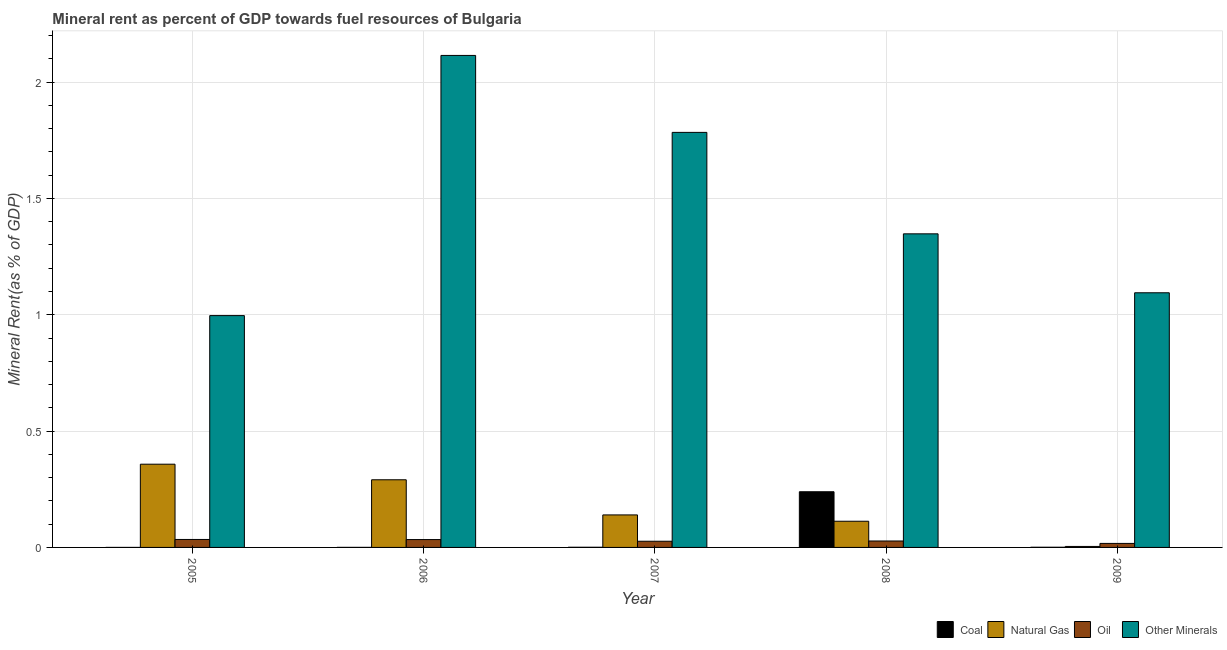How many different coloured bars are there?
Your answer should be compact. 4. Are the number of bars per tick equal to the number of legend labels?
Keep it short and to the point. Yes. How many bars are there on the 2nd tick from the left?
Your answer should be very brief. 4. How many bars are there on the 4th tick from the right?
Offer a very short reply. 4. What is the label of the 1st group of bars from the left?
Ensure brevity in your answer.  2005. What is the natural gas rent in 2009?
Keep it short and to the point. 0. Across all years, what is the maximum  rent of other minerals?
Provide a short and direct response. 2.11. Across all years, what is the minimum natural gas rent?
Offer a terse response. 0. In which year was the natural gas rent maximum?
Provide a succinct answer. 2005. In which year was the coal rent minimum?
Provide a succinct answer. 2005. What is the total oil rent in the graph?
Offer a terse response. 0.14. What is the difference between the  rent of other minerals in 2007 and that in 2008?
Provide a short and direct response. 0.44. What is the difference between the oil rent in 2005 and the  rent of other minerals in 2006?
Give a very brief answer. 0. What is the average coal rent per year?
Offer a terse response. 0.05. In the year 2008, what is the difference between the natural gas rent and coal rent?
Offer a very short reply. 0. What is the ratio of the  rent of other minerals in 2005 to that in 2009?
Provide a succinct answer. 0.91. Is the natural gas rent in 2006 less than that in 2007?
Your answer should be compact. No. Is the difference between the coal rent in 2006 and 2009 greater than the difference between the  rent of other minerals in 2006 and 2009?
Ensure brevity in your answer.  No. What is the difference between the highest and the second highest natural gas rent?
Provide a short and direct response. 0.07. What is the difference between the highest and the lowest  rent of other minerals?
Make the answer very short. 1.12. In how many years, is the natural gas rent greater than the average natural gas rent taken over all years?
Ensure brevity in your answer.  2. What does the 4th bar from the left in 2005 represents?
Make the answer very short. Other Minerals. What does the 4th bar from the right in 2008 represents?
Your response must be concise. Coal. How many bars are there?
Your response must be concise. 20. What is the difference between two consecutive major ticks on the Y-axis?
Offer a terse response. 0.5. Are the values on the major ticks of Y-axis written in scientific E-notation?
Offer a very short reply. No. Does the graph contain any zero values?
Make the answer very short. No. How are the legend labels stacked?
Give a very brief answer. Horizontal. What is the title of the graph?
Your answer should be compact. Mineral rent as percent of GDP towards fuel resources of Bulgaria. What is the label or title of the X-axis?
Your response must be concise. Year. What is the label or title of the Y-axis?
Give a very brief answer. Mineral Rent(as % of GDP). What is the Mineral Rent(as % of GDP) in Coal in 2005?
Ensure brevity in your answer.  6.50114927236494e-5. What is the Mineral Rent(as % of GDP) in Natural Gas in 2005?
Keep it short and to the point. 0.36. What is the Mineral Rent(as % of GDP) of Oil in 2005?
Provide a short and direct response. 0.03. What is the Mineral Rent(as % of GDP) in Other Minerals in 2005?
Your answer should be very brief. 1. What is the Mineral Rent(as % of GDP) of Coal in 2006?
Ensure brevity in your answer.  0. What is the Mineral Rent(as % of GDP) in Natural Gas in 2006?
Provide a short and direct response. 0.29. What is the Mineral Rent(as % of GDP) of Oil in 2006?
Offer a very short reply. 0.03. What is the Mineral Rent(as % of GDP) in Other Minerals in 2006?
Give a very brief answer. 2.11. What is the Mineral Rent(as % of GDP) of Coal in 2007?
Provide a succinct answer. 0. What is the Mineral Rent(as % of GDP) in Natural Gas in 2007?
Make the answer very short. 0.14. What is the Mineral Rent(as % of GDP) of Oil in 2007?
Your answer should be very brief. 0.03. What is the Mineral Rent(as % of GDP) of Other Minerals in 2007?
Your answer should be very brief. 1.78. What is the Mineral Rent(as % of GDP) in Coal in 2008?
Provide a short and direct response. 0.24. What is the Mineral Rent(as % of GDP) of Natural Gas in 2008?
Your answer should be very brief. 0.11. What is the Mineral Rent(as % of GDP) of Oil in 2008?
Your response must be concise. 0.03. What is the Mineral Rent(as % of GDP) of Other Minerals in 2008?
Provide a succinct answer. 1.35. What is the Mineral Rent(as % of GDP) of Coal in 2009?
Your answer should be compact. 0. What is the Mineral Rent(as % of GDP) in Natural Gas in 2009?
Keep it short and to the point. 0. What is the Mineral Rent(as % of GDP) of Oil in 2009?
Your answer should be compact. 0.02. What is the Mineral Rent(as % of GDP) in Other Minerals in 2009?
Make the answer very short. 1.09. Across all years, what is the maximum Mineral Rent(as % of GDP) in Coal?
Provide a succinct answer. 0.24. Across all years, what is the maximum Mineral Rent(as % of GDP) of Natural Gas?
Keep it short and to the point. 0.36. Across all years, what is the maximum Mineral Rent(as % of GDP) in Oil?
Provide a succinct answer. 0.03. Across all years, what is the maximum Mineral Rent(as % of GDP) of Other Minerals?
Give a very brief answer. 2.11. Across all years, what is the minimum Mineral Rent(as % of GDP) in Coal?
Make the answer very short. 6.50114927236494e-5. Across all years, what is the minimum Mineral Rent(as % of GDP) of Natural Gas?
Your answer should be compact. 0. Across all years, what is the minimum Mineral Rent(as % of GDP) in Oil?
Offer a terse response. 0.02. Across all years, what is the minimum Mineral Rent(as % of GDP) in Other Minerals?
Your answer should be very brief. 1. What is the total Mineral Rent(as % of GDP) in Coal in the graph?
Your answer should be compact. 0.24. What is the total Mineral Rent(as % of GDP) of Natural Gas in the graph?
Your response must be concise. 0.91. What is the total Mineral Rent(as % of GDP) of Oil in the graph?
Your response must be concise. 0.14. What is the total Mineral Rent(as % of GDP) of Other Minerals in the graph?
Provide a short and direct response. 7.34. What is the difference between the Mineral Rent(as % of GDP) of Coal in 2005 and that in 2006?
Your answer should be compact. -0. What is the difference between the Mineral Rent(as % of GDP) of Natural Gas in 2005 and that in 2006?
Ensure brevity in your answer.  0.07. What is the difference between the Mineral Rent(as % of GDP) in Other Minerals in 2005 and that in 2006?
Offer a very short reply. -1.12. What is the difference between the Mineral Rent(as % of GDP) of Coal in 2005 and that in 2007?
Your answer should be compact. -0. What is the difference between the Mineral Rent(as % of GDP) of Natural Gas in 2005 and that in 2007?
Provide a succinct answer. 0.22. What is the difference between the Mineral Rent(as % of GDP) of Oil in 2005 and that in 2007?
Give a very brief answer. 0.01. What is the difference between the Mineral Rent(as % of GDP) of Other Minerals in 2005 and that in 2007?
Provide a succinct answer. -0.79. What is the difference between the Mineral Rent(as % of GDP) in Coal in 2005 and that in 2008?
Make the answer very short. -0.24. What is the difference between the Mineral Rent(as % of GDP) of Natural Gas in 2005 and that in 2008?
Ensure brevity in your answer.  0.25. What is the difference between the Mineral Rent(as % of GDP) in Oil in 2005 and that in 2008?
Offer a terse response. 0.01. What is the difference between the Mineral Rent(as % of GDP) in Other Minerals in 2005 and that in 2008?
Provide a short and direct response. -0.35. What is the difference between the Mineral Rent(as % of GDP) of Coal in 2005 and that in 2009?
Give a very brief answer. -0. What is the difference between the Mineral Rent(as % of GDP) in Natural Gas in 2005 and that in 2009?
Offer a terse response. 0.35. What is the difference between the Mineral Rent(as % of GDP) in Oil in 2005 and that in 2009?
Give a very brief answer. 0.02. What is the difference between the Mineral Rent(as % of GDP) of Other Minerals in 2005 and that in 2009?
Give a very brief answer. -0.1. What is the difference between the Mineral Rent(as % of GDP) in Coal in 2006 and that in 2007?
Make the answer very short. -0. What is the difference between the Mineral Rent(as % of GDP) of Natural Gas in 2006 and that in 2007?
Your answer should be very brief. 0.15. What is the difference between the Mineral Rent(as % of GDP) of Oil in 2006 and that in 2007?
Offer a terse response. 0.01. What is the difference between the Mineral Rent(as % of GDP) in Other Minerals in 2006 and that in 2007?
Offer a very short reply. 0.33. What is the difference between the Mineral Rent(as % of GDP) of Coal in 2006 and that in 2008?
Ensure brevity in your answer.  -0.24. What is the difference between the Mineral Rent(as % of GDP) of Natural Gas in 2006 and that in 2008?
Ensure brevity in your answer.  0.18. What is the difference between the Mineral Rent(as % of GDP) in Oil in 2006 and that in 2008?
Your answer should be very brief. 0.01. What is the difference between the Mineral Rent(as % of GDP) in Other Minerals in 2006 and that in 2008?
Your answer should be compact. 0.77. What is the difference between the Mineral Rent(as % of GDP) in Coal in 2006 and that in 2009?
Provide a succinct answer. -0. What is the difference between the Mineral Rent(as % of GDP) of Natural Gas in 2006 and that in 2009?
Give a very brief answer. 0.29. What is the difference between the Mineral Rent(as % of GDP) of Oil in 2006 and that in 2009?
Make the answer very short. 0.02. What is the difference between the Mineral Rent(as % of GDP) in Other Minerals in 2006 and that in 2009?
Make the answer very short. 1.02. What is the difference between the Mineral Rent(as % of GDP) in Coal in 2007 and that in 2008?
Offer a terse response. -0.24. What is the difference between the Mineral Rent(as % of GDP) in Natural Gas in 2007 and that in 2008?
Your answer should be very brief. 0.03. What is the difference between the Mineral Rent(as % of GDP) in Oil in 2007 and that in 2008?
Provide a short and direct response. -0. What is the difference between the Mineral Rent(as % of GDP) of Other Minerals in 2007 and that in 2008?
Keep it short and to the point. 0.44. What is the difference between the Mineral Rent(as % of GDP) in Coal in 2007 and that in 2009?
Make the answer very short. -0. What is the difference between the Mineral Rent(as % of GDP) of Natural Gas in 2007 and that in 2009?
Your answer should be very brief. 0.14. What is the difference between the Mineral Rent(as % of GDP) of Oil in 2007 and that in 2009?
Provide a succinct answer. 0.01. What is the difference between the Mineral Rent(as % of GDP) in Other Minerals in 2007 and that in 2009?
Provide a succinct answer. 0.69. What is the difference between the Mineral Rent(as % of GDP) of Coal in 2008 and that in 2009?
Your answer should be compact. 0.24. What is the difference between the Mineral Rent(as % of GDP) in Natural Gas in 2008 and that in 2009?
Offer a very short reply. 0.11. What is the difference between the Mineral Rent(as % of GDP) in Oil in 2008 and that in 2009?
Provide a short and direct response. 0.01. What is the difference between the Mineral Rent(as % of GDP) of Other Minerals in 2008 and that in 2009?
Your answer should be very brief. 0.25. What is the difference between the Mineral Rent(as % of GDP) of Coal in 2005 and the Mineral Rent(as % of GDP) of Natural Gas in 2006?
Ensure brevity in your answer.  -0.29. What is the difference between the Mineral Rent(as % of GDP) in Coal in 2005 and the Mineral Rent(as % of GDP) in Oil in 2006?
Provide a succinct answer. -0.03. What is the difference between the Mineral Rent(as % of GDP) of Coal in 2005 and the Mineral Rent(as % of GDP) of Other Minerals in 2006?
Provide a short and direct response. -2.11. What is the difference between the Mineral Rent(as % of GDP) of Natural Gas in 2005 and the Mineral Rent(as % of GDP) of Oil in 2006?
Your answer should be very brief. 0.32. What is the difference between the Mineral Rent(as % of GDP) of Natural Gas in 2005 and the Mineral Rent(as % of GDP) of Other Minerals in 2006?
Keep it short and to the point. -1.76. What is the difference between the Mineral Rent(as % of GDP) in Oil in 2005 and the Mineral Rent(as % of GDP) in Other Minerals in 2006?
Your answer should be compact. -2.08. What is the difference between the Mineral Rent(as % of GDP) of Coal in 2005 and the Mineral Rent(as % of GDP) of Natural Gas in 2007?
Keep it short and to the point. -0.14. What is the difference between the Mineral Rent(as % of GDP) of Coal in 2005 and the Mineral Rent(as % of GDP) of Oil in 2007?
Your answer should be compact. -0.03. What is the difference between the Mineral Rent(as % of GDP) in Coal in 2005 and the Mineral Rent(as % of GDP) in Other Minerals in 2007?
Offer a terse response. -1.78. What is the difference between the Mineral Rent(as % of GDP) of Natural Gas in 2005 and the Mineral Rent(as % of GDP) of Oil in 2007?
Your answer should be very brief. 0.33. What is the difference between the Mineral Rent(as % of GDP) of Natural Gas in 2005 and the Mineral Rent(as % of GDP) of Other Minerals in 2007?
Provide a succinct answer. -1.43. What is the difference between the Mineral Rent(as % of GDP) in Oil in 2005 and the Mineral Rent(as % of GDP) in Other Minerals in 2007?
Keep it short and to the point. -1.75. What is the difference between the Mineral Rent(as % of GDP) in Coal in 2005 and the Mineral Rent(as % of GDP) in Natural Gas in 2008?
Make the answer very short. -0.11. What is the difference between the Mineral Rent(as % of GDP) in Coal in 2005 and the Mineral Rent(as % of GDP) in Oil in 2008?
Give a very brief answer. -0.03. What is the difference between the Mineral Rent(as % of GDP) in Coal in 2005 and the Mineral Rent(as % of GDP) in Other Minerals in 2008?
Your response must be concise. -1.35. What is the difference between the Mineral Rent(as % of GDP) in Natural Gas in 2005 and the Mineral Rent(as % of GDP) in Oil in 2008?
Your answer should be very brief. 0.33. What is the difference between the Mineral Rent(as % of GDP) of Natural Gas in 2005 and the Mineral Rent(as % of GDP) of Other Minerals in 2008?
Provide a succinct answer. -0.99. What is the difference between the Mineral Rent(as % of GDP) of Oil in 2005 and the Mineral Rent(as % of GDP) of Other Minerals in 2008?
Your answer should be very brief. -1.31. What is the difference between the Mineral Rent(as % of GDP) in Coal in 2005 and the Mineral Rent(as % of GDP) in Natural Gas in 2009?
Make the answer very short. -0. What is the difference between the Mineral Rent(as % of GDP) of Coal in 2005 and the Mineral Rent(as % of GDP) of Oil in 2009?
Provide a short and direct response. -0.02. What is the difference between the Mineral Rent(as % of GDP) in Coal in 2005 and the Mineral Rent(as % of GDP) in Other Minerals in 2009?
Provide a short and direct response. -1.09. What is the difference between the Mineral Rent(as % of GDP) of Natural Gas in 2005 and the Mineral Rent(as % of GDP) of Oil in 2009?
Keep it short and to the point. 0.34. What is the difference between the Mineral Rent(as % of GDP) of Natural Gas in 2005 and the Mineral Rent(as % of GDP) of Other Minerals in 2009?
Give a very brief answer. -0.74. What is the difference between the Mineral Rent(as % of GDP) in Oil in 2005 and the Mineral Rent(as % of GDP) in Other Minerals in 2009?
Make the answer very short. -1.06. What is the difference between the Mineral Rent(as % of GDP) of Coal in 2006 and the Mineral Rent(as % of GDP) of Natural Gas in 2007?
Give a very brief answer. -0.14. What is the difference between the Mineral Rent(as % of GDP) of Coal in 2006 and the Mineral Rent(as % of GDP) of Oil in 2007?
Your answer should be compact. -0.03. What is the difference between the Mineral Rent(as % of GDP) in Coal in 2006 and the Mineral Rent(as % of GDP) in Other Minerals in 2007?
Provide a succinct answer. -1.78. What is the difference between the Mineral Rent(as % of GDP) of Natural Gas in 2006 and the Mineral Rent(as % of GDP) of Oil in 2007?
Your answer should be very brief. 0.26. What is the difference between the Mineral Rent(as % of GDP) in Natural Gas in 2006 and the Mineral Rent(as % of GDP) in Other Minerals in 2007?
Provide a short and direct response. -1.49. What is the difference between the Mineral Rent(as % of GDP) in Oil in 2006 and the Mineral Rent(as % of GDP) in Other Minerals in 2007?
Offer a terse response. -1.75. What is the difference between the Mineral Rent(as % of GDP) in Coal in 2006 and the Mineral Rent(as % of GDP) in Natural Gas in 2008?
Make the answer very short. -0.11. What is the difference between the Mineral Rent(as % of GDP) of Coal in 2006 and the Mineral Rent(as % of GDP) of Oil in 2008?
Make the answer very short. -0.03. What is the difference between the Mineral Rent(as % of GDP) in Coal in 2006 and the Mineral Rent(as % of GDP) in Other Minerals in 2008?
Your answer should be compact. -1.35. What is the difference between the Mineral Rent(as % of GDP) of Natural Gas in 2006 and the Mineral Rent(as % of GDP) of Oil in 2008?
Provide a short and direct response. 0.26. What is the difference between the Mineral Rent(as % of GDP) of Natural Gas in 2006 and the Mineral Rent(as % of GDP) of Other Minerals in 2008?
Make the answer very short. -1.06. What is the difference between the Mineral Rent(as % of GDP) in Oil in 2006 and the Mineral Rent(as % of GDP) in Other Minerals in 2008?
Make the answer very short. -1.31. What is the difference between the Mineral Rent(as % of GDP) of Coal in 2006 and the Mineral Rent(as % of GDP) of Natural Gas in 2009?
Make the answer very short. -0. What is the difference between the Mineral Rent(as % of GDP) in Coal in 2006 and the Mineral Rent(as % of GDP) in Oil in 2009?
Your answer should be very brief. -0.02. What is the difference between the Mineral Rent(as % of GDP) of Coal in 2006 and the Mineral Rent(as % of GDP) of Other Minerals in 2009?
Offer a very short reply. -1.09. What is the difference between the Mineral Rent(as % of GDP) of Natural Gas in 2006 and the Mineral Rent(as % of GDP) of Oil in 2009?
Provide a succinct answer. 0.27. What is the difference between the Mineral Rent(as % of GDP) in Natural Gas in 2006 and the Mineral Rent(as % of GDP) in Other Minerals in 2009?
Your answer should be very brief. -0.8. What is the difference between the Mineral Rent(as % of GDP) in Oil in 2006 and the Mineral Rent(as % of GDP) in Other Minerals in 2009?
Offer a very short reply. -1.06. What is the difference between the Mineral Rent(as % of GDP) in Coal in 2007 and the Mineral Rent(as % of GDP) in Natural Gas in 2008?
Make the answer very short. -0.11. What is the difference between the Mineral Rent(as % of GDP) in Coal in 2007 and the Mineral Rent(as % of GDP) in Oil in 2008?
Your answer should be very brief. -0.03. What is the difference between the Mineral Rent(as % of GDP) of Coal in 2007 and the Mineral Rent(as % of GDP) of Other Minerals in 2008?
Make the answer very short. -1.35. What is the difference between the Mineral Rent(as % of GDP) in Natural Gas in 2007 and the Mineral Rent(as % of GDP) in Oil in 2008?
Provide a succinct answer. 0.11. What is the difference between the Mineral Rent(as % of GDP) in Natural Gas in 2007 and the Mineral Rent(as % of GDP) in Other Minerals in 2008?
Offer a terse response. -1.21. What is the difference between the Mineral Rent(as % of GDP) of Oil in 2007 and the Mineral Rent(as % of GDP) of Other Minerals in 2008?
Keep it short and to the point. -1.32. What is the difference between the Mineral Rent(as % of GDP) in Coal in 2007 and the Mineral Rent(as % of GDP) in Natural Gas in 2009?
Make the answer very short. -0. What is the difference between the Mineral Rent(as % of GDP) of Coal in 2007 and the Mineral Rent(as % of GDP) of Oil in 2009?
Offer a very short reply. -0.02. What is the difference between the Mineral Rent(as % of GDP) in Coal in 2007 and the Mineral Rent(as % of GDP) in Other Minerals in 2009?
Your response must be concise. -1.09. What is the difference between the Mineral Rent(as % of GDP) of Natural Gas in 2007 and the Mineral Rent(as % of GDP) of Oil in 2009?
Your answer should be compact. 0.12. What is the difference between the Mineral Rent(as % of GDP) in Natural Gas in 2007 and the Mineral Rent(as % of GDP) in Other Minerals in 2009?
Your answer should be very brief. -0.95. What is the difference between the Mineral Rent(as % of GDP) in Oil in 2007 and the Mineral Rent(as % of GDP) in Other Minerals in 2009?
Keep it short and to the point. -1.07. What is the difference between the Mineral Rent(as % of GDP) in Coal in 2008 and the Mineral Rent(as % of GDP) in Natural Gas in 2009?
Your answer should be compact. 0.24. What is the difference between the Mineral Rent(as % of GDP) in Coal in 2008 and the Mineral Rent(as % of GDP) in Oil in 2009?
Your answer should be very brief. 0.22. What is the difference between the Mineral Rent(as % of GDP) in Coal in 2008 and the Mineral Rent(as % of GDP) in Other Minerals in 2009?
Provide a succinct answer. -0.86. What is the difference between the Mineral Rent(as % of GDP) in Natural Gas in 2008 and the Mineral Rent(as % of GDP) in Oil in 2009?
Provide a succinct answer. 0.1. What is the difference between the Mineral Rent(as % of GDP) in Natural Gas in 2008 and the Mineral Rent(as % of GDP) in Other Minerals in 2009?
Provide a short and direct response. -0.98. What is the difference between the Mineral Rent(as % of GDP) of Oil in 2008 and the Mineral Rent(as % of GDP) of Other Minerals in 2009?
Ensure brevity in your answer.  -1.07. What is the average Mineral Rent(as % of GDP) of Coal per year?
Offer a terse response. 0.05. What is the average Mineral Rent(as % of GDP) in Natural Gas per year?
Provide a short and direct response. 0.18. What is the average Mineral Rent(as % of GDP) of Oil per year?
Provide a short and direct response. 0.03. What is the average Mineral Rent(as % of GDP) of Other Minerals per year?
Provide a short and direct response. 1.47. In the year 2005, what is the difference between the Mineral Rent(as % of GDP) in Coal and Mineral Rent(as % of GDP) in Natural Gas?
Ensure brevity in your answer.  -0.36. In the year 2005, what is the difference between the Mineral Rent(as % of GDP) of Coal and Mineral Rent(as % of GDP) of Oil?
Provide a short and direct response. -0.03. In the year 2005, what is the difference between the Mineral Rent(as % of GDP) of Coal and Mineral Rent(as % of GDP) of Other Minerals?
Provide a short and direct response. -1. In the year 2005, what is the difference between the Mineral Rent(as % of GDP) in Natural Gas and Mineral Rent(as % of GDP) in Oil?
Your response must be concise. 0.32. In the year 2005, what is the difference between the Mineral Rent(as % of GDP) in Natural Gas and Mineral Rent(as % of GDP) in Other Minerals?
Ensure brevity in your answer.  -0.64. In the year 2005, what is the difference between the Mineral Rent(as % of GDP) of Oil and Mineral Rent(as % of GDP) of Other Minerals?
Ensure brevity in your answer.  -0.96. In the year 2006, what is the difference between the Mineral Rent(as % of GDP) of Coal and Mineral Rent(as % of GDP) of Natural Gas?
Make the answer very short. -0.29. In the year 2006, what is the difference between the Mineral Rent(as % of GDP) of Coal and Mineral Rent(as % of GDP) of Oil?
Keep it short and to the point. -0.03. In the year 2006, what is the difference between the Mineral Rent(as % of GDP) in Coal and Mineral Rent(as % of GDP) in Other Minerals?
Offer a very short reply. -2.11. In the year 2006, what is the difference between the Mineral Rent(as % of GDP) of Natural Gas and Mineral Rent(as % of GDP) of Oil?
Your answer should be very brief. 0.26. In the year 2006, what is the difference between the Mineral Rent(as % of GDP) of Natural Gas and Mineral Rent(as % of GDP) of Other Minerals?
Offer a terse response. -1.82. In the year 2006, what is the difference between the Mineral Rent(as % of GDP) in Oil and Mineral Rent(as % of GDP) in Other Minerals?
Your response must be concise. -2.08. In the year 2007, what is the difference between the Mineral Rent(as % of GDP) of Coal and Mineral Rent(as % of GDP) of Natural Gas?
Provide a short and direct response. -0.14. In the year 2007, what is the difference between the Mineral Rent(as % of GDP) of Coal and Mineral Rent(as % of GDP) of Oil?
Offer a terse response. -0.03. In the year 2007, what is the difference between the Mineral Rent(as % of GDP) in Coal and Mineral Rent(as % of GDP) in Other Minerals?
Offer a very short reply. -1.78. In the year 2007, what is the difference between the Mineral Rent(as % of GDP) in Natural Gas and Mineral Rent(as % of GDP) in Oil?
Ensure brevity in your answer.  0.11. In the year 2007, what is the difference between the Mineral Rent(as % of GDP) of Natural Gas and Mineral Rent(as % of GDP) of Other Minerals?
Your answer should be very brief. -1.64. In the year 2007, what is the difference between the Mineral Rent(as % of GDP) in Oil and Mineral Rent(as % of GDP) in Other Minerals?
Offer a very short reply. -1.76. In the year 2008, what is the difference between the Mineral Rent(as % of GDP) of Coal and Mineral Rent(as % of GDP) of Natural Gas?
Provide a succinct answer. 0.13. In the year 2008, what is the difference between the Mineral Rent(as % of GDP) in Coal and Mineral Rent(as % of GDP) in Oil?
Give a very brief answer. 0.21. In the year 2008, what is the difference between the Mineral Rent(as % of GDP) of Coal and Mineral Rent(as % of GDP) of Other Minerals?
Your answer should be very brief. -1.11. In the year 2008, what is the difference between the Mineral Rent(as % of GDP) of Natural Gas and Mineral Rent(as % of GDP) of Oil?
Your answer should be compact. 0.08. In the year 2008, what is the difference between the Mineral Rent(as % of GDP) of Natural Gas and Mineral Rent(as % of GDP) of Other Minerals?
Offer a very short reply. -1.24. In the year 2008, what is the difference between the Mineral Rent(as % of GDP) of Oil and Mineral Rent(as % of GDP) of Other Minerals?
Provide a succinct answer. -1.32. In the year 2009, what is the difference between the Mineral Rent(as % of GDP) of Coal and Mineral Rent(as % of GDP) of Natural Gas?
Your answer should be very brief. -0. In the year 2009, what is the difference between the Mineral Rent(as % of GDP) of Coal and Mineral Rent(as % of GDP) of Oil?
Give a very brief answer. -0.02. In the year 2009, what is the difference between the Mineral Rent(as % of GDP) in Coal and Mineral Rent(as % of GDP) in Other Minerals?
Keep it short and to the point. -1.09. In the year 2009, what is the difference between the Mineral Rent(as % of GDP) of Natural Gas and Mineral Rent(as % of GDP) of Oil?
Your answer should be very brief. -0.01. In the year 2009, what is the difference between the Mineral Rent(as % of GDP) in Natural Gas and Mineral Rent(as % of GDP) in Other Minerals?
Make the answer very short. -1.09. In the year 2009, what is the difference between the Mineral Rent(as % of GDP) in Oil and Mineral Rent(as % of GDP) in Other Minerals?
Offer a terse response. -1.08. What is the ratio of the Mineral Rent(as % of GDP) in Coal in 2005 to that in 2006?
Offer a terse response. 0.23. What is the ratio of the Mineral Rent(as % of GDP) in Natural Gas in 2005 to that in 2006?
Keep it short and to the point. 1.23. What is the ratio of the Mineral Rent(as % of GDP) in Oil in 2005 to that in 2006?
Provide a short and direct response. 1.01. What is the ratio of the Mineral Rent(as % of GDP) of Other Minerals in 2005 to that in 2006?
Keep it short and to the point. 0.47. What is the ratio of the Mineral Rent(as % of GDP) in Coal in 2005 to that in 2007?
Provide a short and direct response. 0.09. What is the ratio of the Mineral Rent(as % of GDP) in Natural Gas in 2005 to that in 2007?
Your answer should be compact. 2.56. What is the ratio of the Mineral Rent(as % of GDP) of Oil in 2005 to that in 2007?
Offer a terse response. 1.29. What is the ratio of the Mineral Rent(as % of GDP) of Other Minerals in 2005 to that in 2007?
Ensure brevity in your answer.  0.56. What is the ratio of the Mineral Rent(as % of GDP) of Natural Gas in 2005 to that in 2008?
Your response must be concise. 3.18. What is the ratio of the Mineral Rent(as % of GDP) of Oil in 2005 to that in 2008?
Offer a very short reply. 1.24. What is the ratio of the Mineral Rent(as % of GDP) in Other Minerals in 2005 to that in 2008?
Your answer should be compact. 0.74. What is the ratio of the Mineral Rent(as % of GDP) in Coal in 2005 to that in 2009?
Make the answer very short. 0.08. What is the ratio of the Mineral Rent(as % of GDP) of Natural Gas in 2005 to that in 2009?
Offer a very short reply. 85.31. What is the ratio of the Mineral Rent(as % of GDP) of Oil in 2005 to that in 2009?
Provide a short and direct response. 1.98. What is the ratio of the Mineral Rent(as % of GDP) of Other Minerals in 2005 to that in 2009?
Your answer should be very brief. 0.91. What is the ratio of the Mineral Rent(as % of GDP) in Coal in 2006 to that in 2007?
Your answer should be compact. 0.4. What is the ratio of the Mineral Rent(as % of GDP) of Natural Gas in 2006 to that in 2007?
Your answer should be very brief. 2.08. What is the ratio of the Mineral Rent(as % of GDP) of Oil in 2006 to that in 2007?
Make the answer very short. 1.27. What is the ratio of the Mineral Rent(as % of GDP) of Other Minerals in 2006 to that in 2007?
Provide a succinct answer. 1.19. What is the ratio of the Mineral Rent(as % of GDP) in Coal in 2006 to that in 2008?
Your answer should be very brief. 0. What is the ratio of the Mineral Rent(as % of GDP) of Natural Gas in 2006 to that in 2008?
Ensure brevity in your answer.  2.58. What is the ratio of the Mineral Rent(as % of GDP) of Oil in 2006 to that in 2008?
Provide a short and direct response. 1.22. What is the ratio of the Mineral Rent(as % of GDP) in Other Minerals in 2006 to that in 2008?
Make the answer very short. 1.57. What is the ratio of the Mineral Rent(as % of GDP) in Coal in 2006 to that in 2009?
Provide a succinct answer. 0.35. What is the ratio of the Mineral Rent(as % of GDP) of Natural Gas in 2006 to that in 2009?
Offer a very short reply. 69.34. What is the ratio of the Mineral Rent(as % of GDP) in Oil in 2006 to that in 2009?
Ensure brevity in your answer.  1.96. What is the ratio of the Mineral Rent(as % of GDP) in Other Minerals in 2006 to that in 2009?
Your response must be concise. 1.93. What is the ratio of the Mineral Rent(as % of GDP) in Coal in 2007 to that in 2008?
Ensure brevity in your answer.  0. What is the ratio of the Mineral Rent(as % of GDP) in Natural Gas in 2007 to that in 2008?
Your answer should be compact. 1.24. What is the ratio of the Mineral Rent(as % of GDP) of Oil in 2007 to that in 2008?
Offer a very short reply. 0.96. What is the ratio of the Mineral Rent(as % of GDP) in Other Minerals in 2007 to that in 2008?
Offer a very short reply. 1.32. What is the ratio of the Mineral Rent(as % of GDP) of Coal in 2007 to that in 2009?
Make the answer very short. 0.88. What is the ratio of the Mineral Rent(as % of GDP) in Natural Gas in 2007 to that in 2009?
Ensure brevity in your answer.  33.32. What is the ratio of the Mineral Rent(as % of GDP) of Oil in 2007 to that in 2009?
Your answer should be compact. 1.54. What is the ratio of the Mineral Rent(as % of GDP) of Other Minerals in 2007 to that in 2009?
Your answer should be very brief. 1.63. What is the ratio of the Mineral Rent(as % of GDP) in Coal in 2008 to that in 2009?
Provide a short and direct response. 295.92. What is the ratio of the Mineral Rent(as % of GDP) in Natural Gas in 2008 to that in 2009?
Provide a short and direct response. 26.83. What is the ratio of the Mineral Rent(as % of GDP) of Oil in 2008 to that in 2009?
Offer a terse response. 1.6. What is the ratio of the Mineral Rent(as % of GDP) of Other Minerals in 2008 to that in 2009?
Provide a short and direct response. 1.23. What is the difference between the highest and the second highest Mineral Rent(as % of GDP) in Coal?
Your response must be concise. 0.24. What is the difference between the highest and the second highest Mineral Rent(as % of GDP) of Natural Gas?
Make the answer very short. 0.07. What is the difference between the highest and the second highest Mineral Rent(as % of GDP) of Oil?
Your answer should be very brief. 0. What is the difference between the highest and the second highest Mineral Rent(as % of GDP) in Other Minerals?
Ensure brevity in your answer.  0.33. What is the difference between the highest and the lowest Mineral Rent(as % of GDP) of Coal?
Give a very brief answer. 0.24. What is the difference between the highest and the lowest Mineral Rent(as % of GDP) of Natural Gas?
Provide a short and direct response. 0.35. What is the difference between the highest and the lowest Mineral Rent(as % of GDP) of Oil?
Offer a very short reply. 0.02. What is the difference between the highest and the lowest Mineral Rent(as % of GDP) of Other Minerals?
Offer a very short reply. 1.12. 